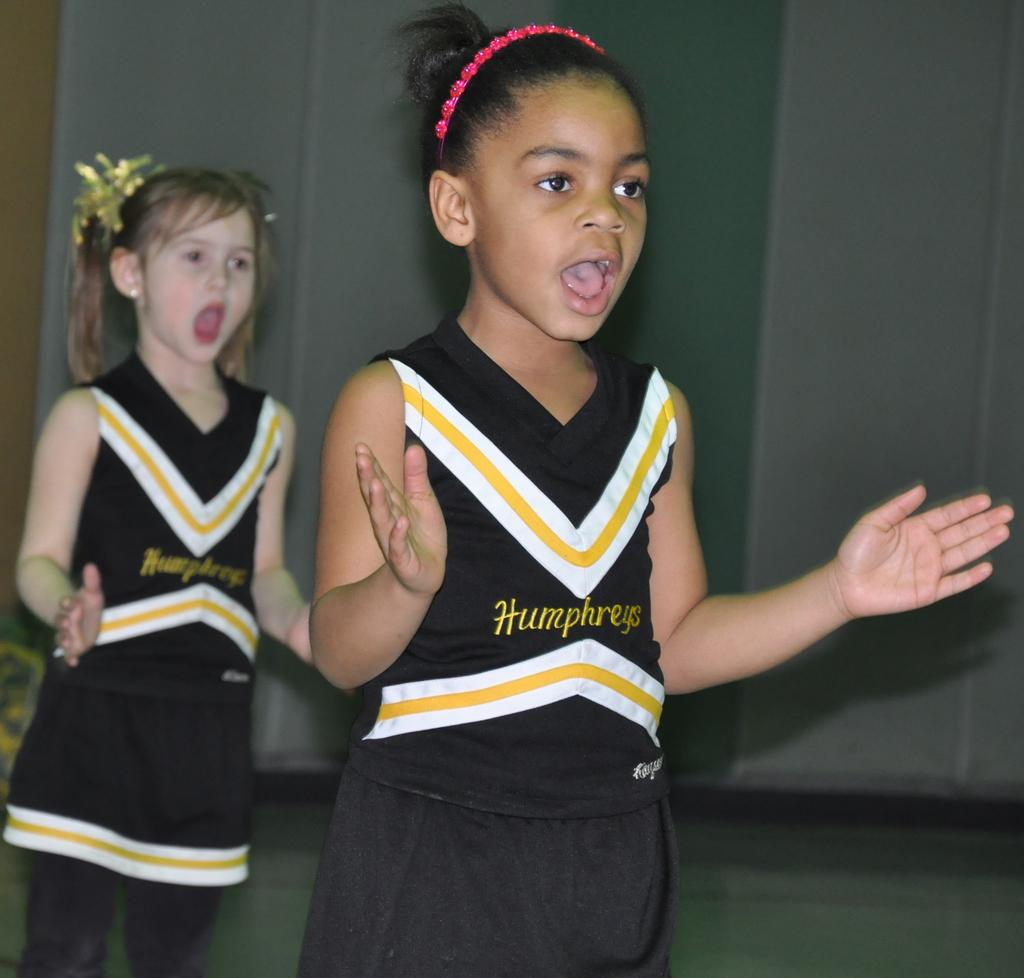<image>
Offer a succinct explanation of the picture presented. Two young girls with Humphreys cheerleading uniforms on practice a cheer. 